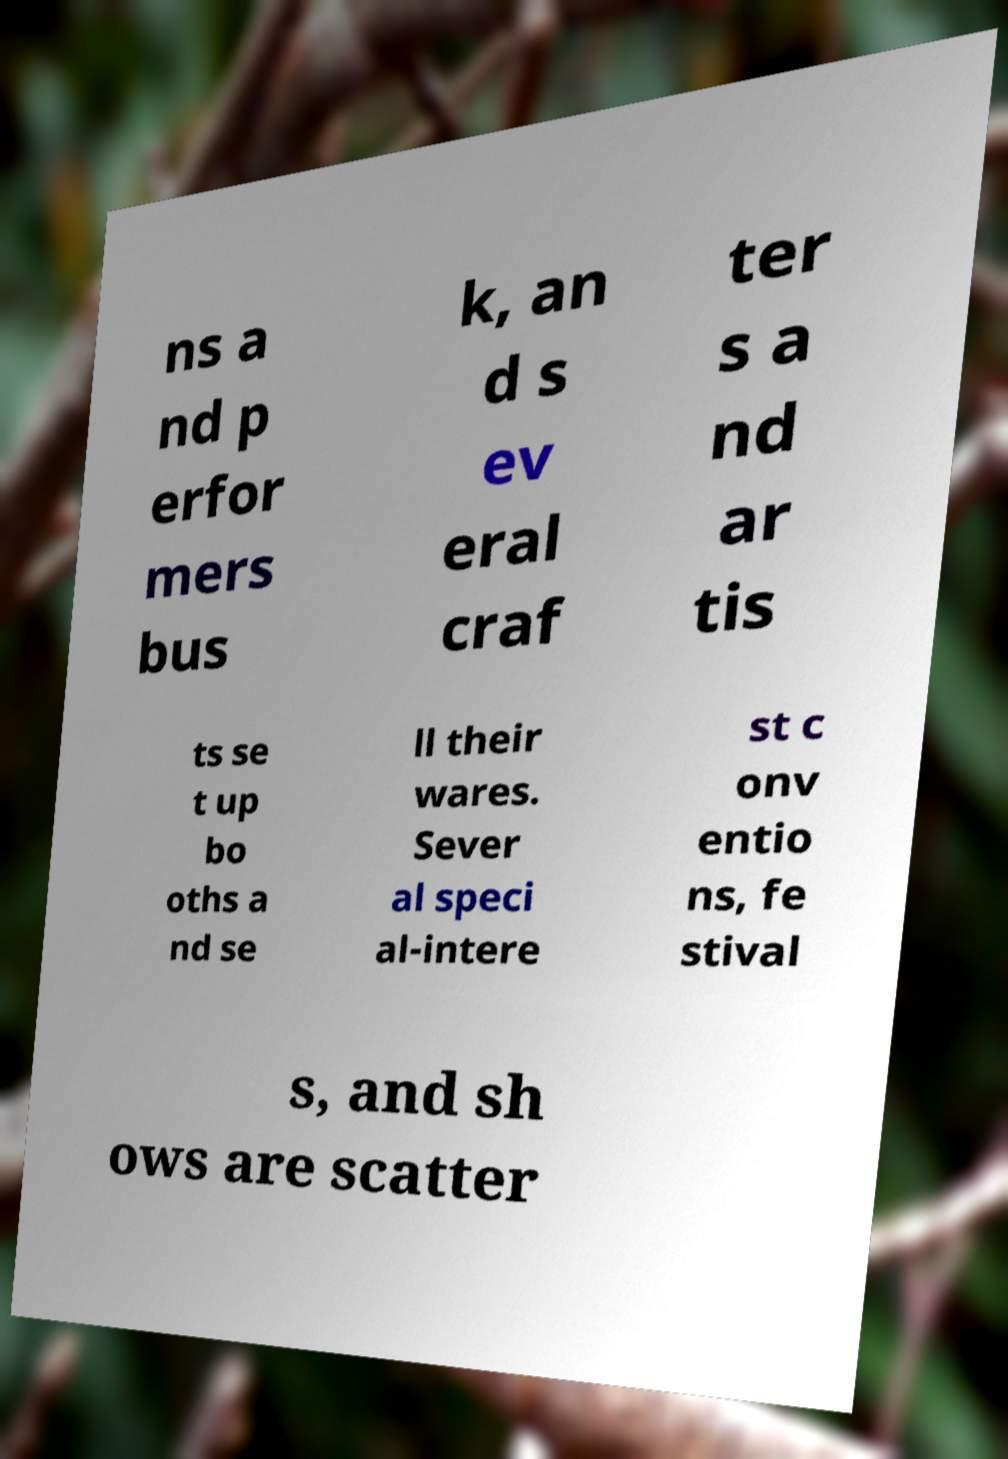Please read and relay the text visible in this image. What does it say? ns a nd p erfor mers bus k, an d s ev eral craf ter s a nd ar tis ts se t up bo oths a nd se ll their wares. Sever al speci al-intere st c onv entio ns, fe stival s, and sh ows are scatter 